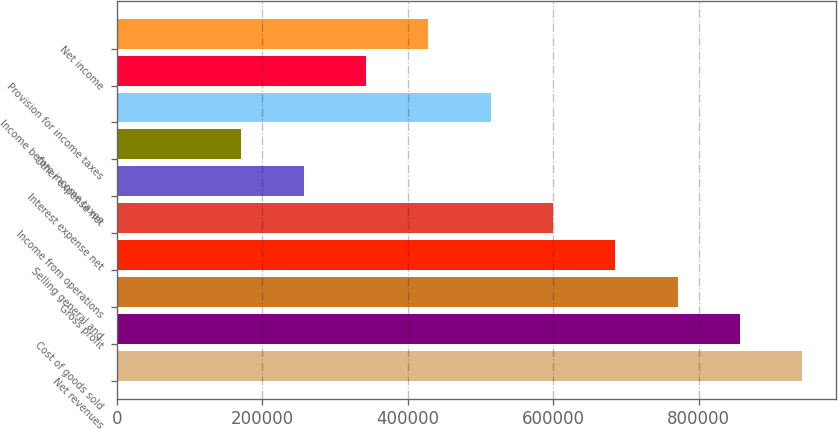Convert chart to OTSL. <chart><loc_0><loc_0><loc_500><loc_500><bar_chart><fcel>Net revenues<fcel>Cost of goods sold<fcel>Gross profit<fcel>Selling general and<fcel>Income from operations<fcel>Interest expense net<fcel>Other expense net<fcel>Income before income taxes<fcel>Provision for income taxes<fcel>Net income<nl><fcel>942052<fcel>856411<fcel>770770<fcel>685129<fcel>599488<fcel>256924<fcel>171283<fcel>513847<fcel>342565<fcel>428206<nl></chart> 